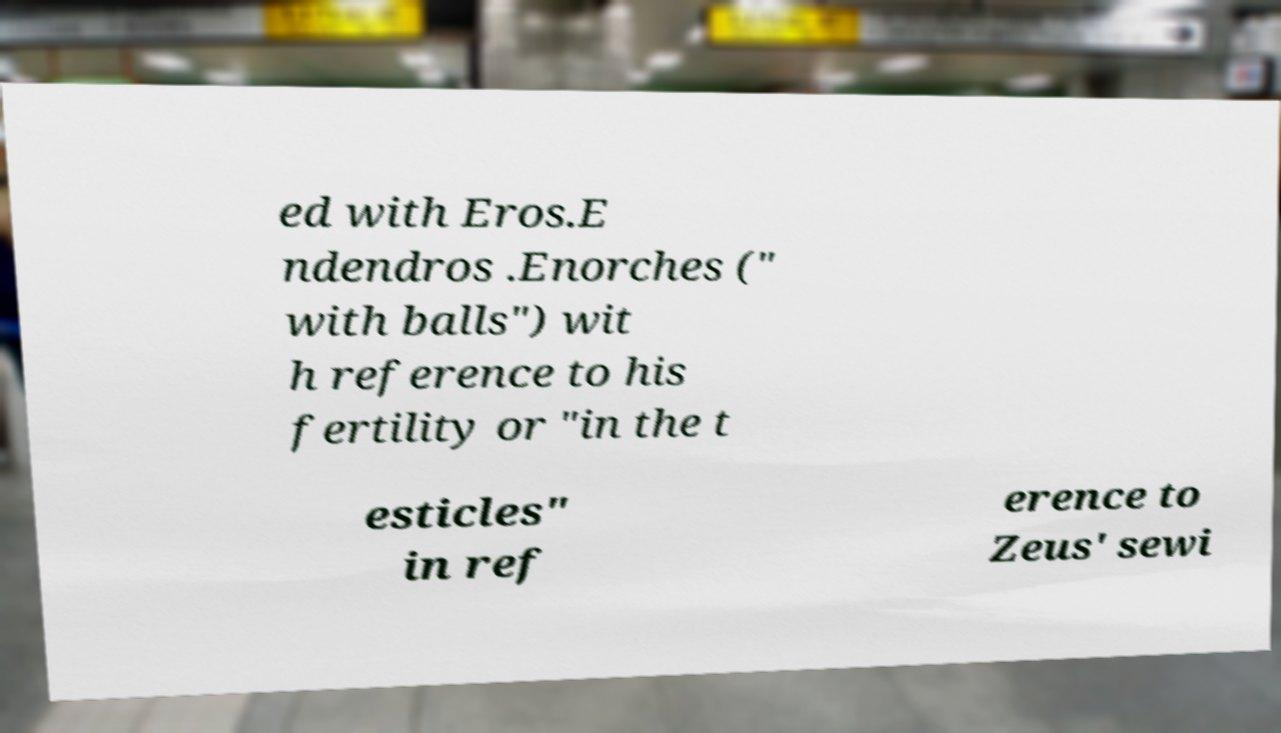Could you extract and type out the text from this image? ed with Eros.E ndendros .Enorches (" with balls") wit h reference to his fertility or "in the t esticles" in ref erence to Zeus' sewi 